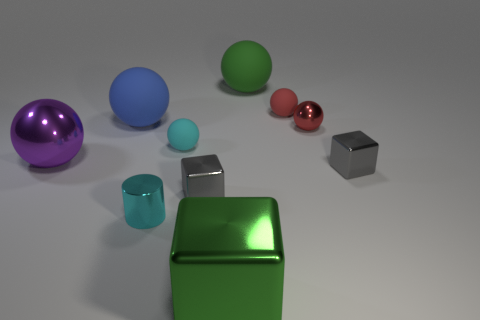Subtract all gray blocks. How many were subtracted if there are1gray blocks left? 1 Subtract all green shiny cubes. How many cubes are left? 2 Subtract all green blocks. How many blocks are left? 2 Subtract all blocks. How many objects are left? 7 Subtract 0 cyan blocks. How many objects are left? 10 Subtract 2 balls. How many balls are left? 4 Subtract all brown cubes. Subtract all blue cylinders. How many cubes are left? 3 Subtract all purple balls. How many gray cubes are left? 2 Subtract all large brown metallic cubes. Subtract all tiny cyan rubber spheres. How many objects are left? 9 Add 6 red metallic spheres. How many red metallic spheres are left? 7 